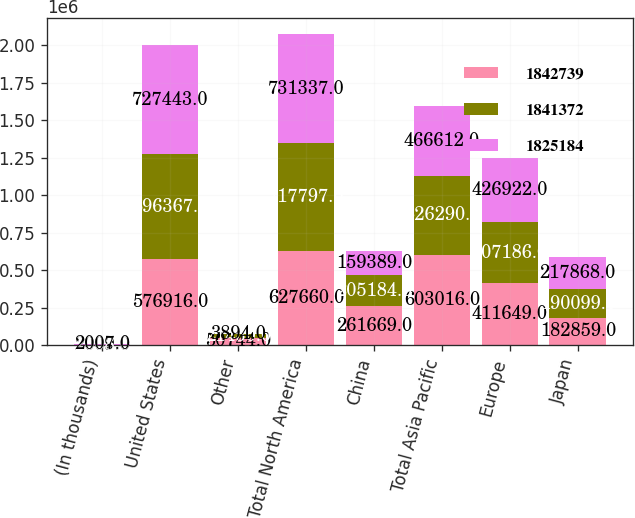Convert chart. <chart><loc_0><loc_0><loc_500><loc_500><stacked_bar_chart><ecel><fcel>(In thousands)<fcel>United States<fcel>Other<fcel>Total North America<fcel>China<fcel>Total Asia Pacific<fcel>Europe<fcel>Japan<nl><fcel>1.84274e+06<fcel>2009<fcel>576916<fcel>50744<fcel>627660<fcel>261669<fcel>603016<fcel>411649<fcel>182859<nl><fcel>1.84137e+06<fcel>2008<fcel>696367<fcel>21430<fcel>717797<fcel>205184<fcel>526290<fcel>407186<fcel>190099<nl><fcel>1.82518e+06<fcel>2007<fcel>727443<fcel>3894<fcel>731337<fcel>159389<fcel>466612<fcel>426922<fcel>217868<nl></chart> 